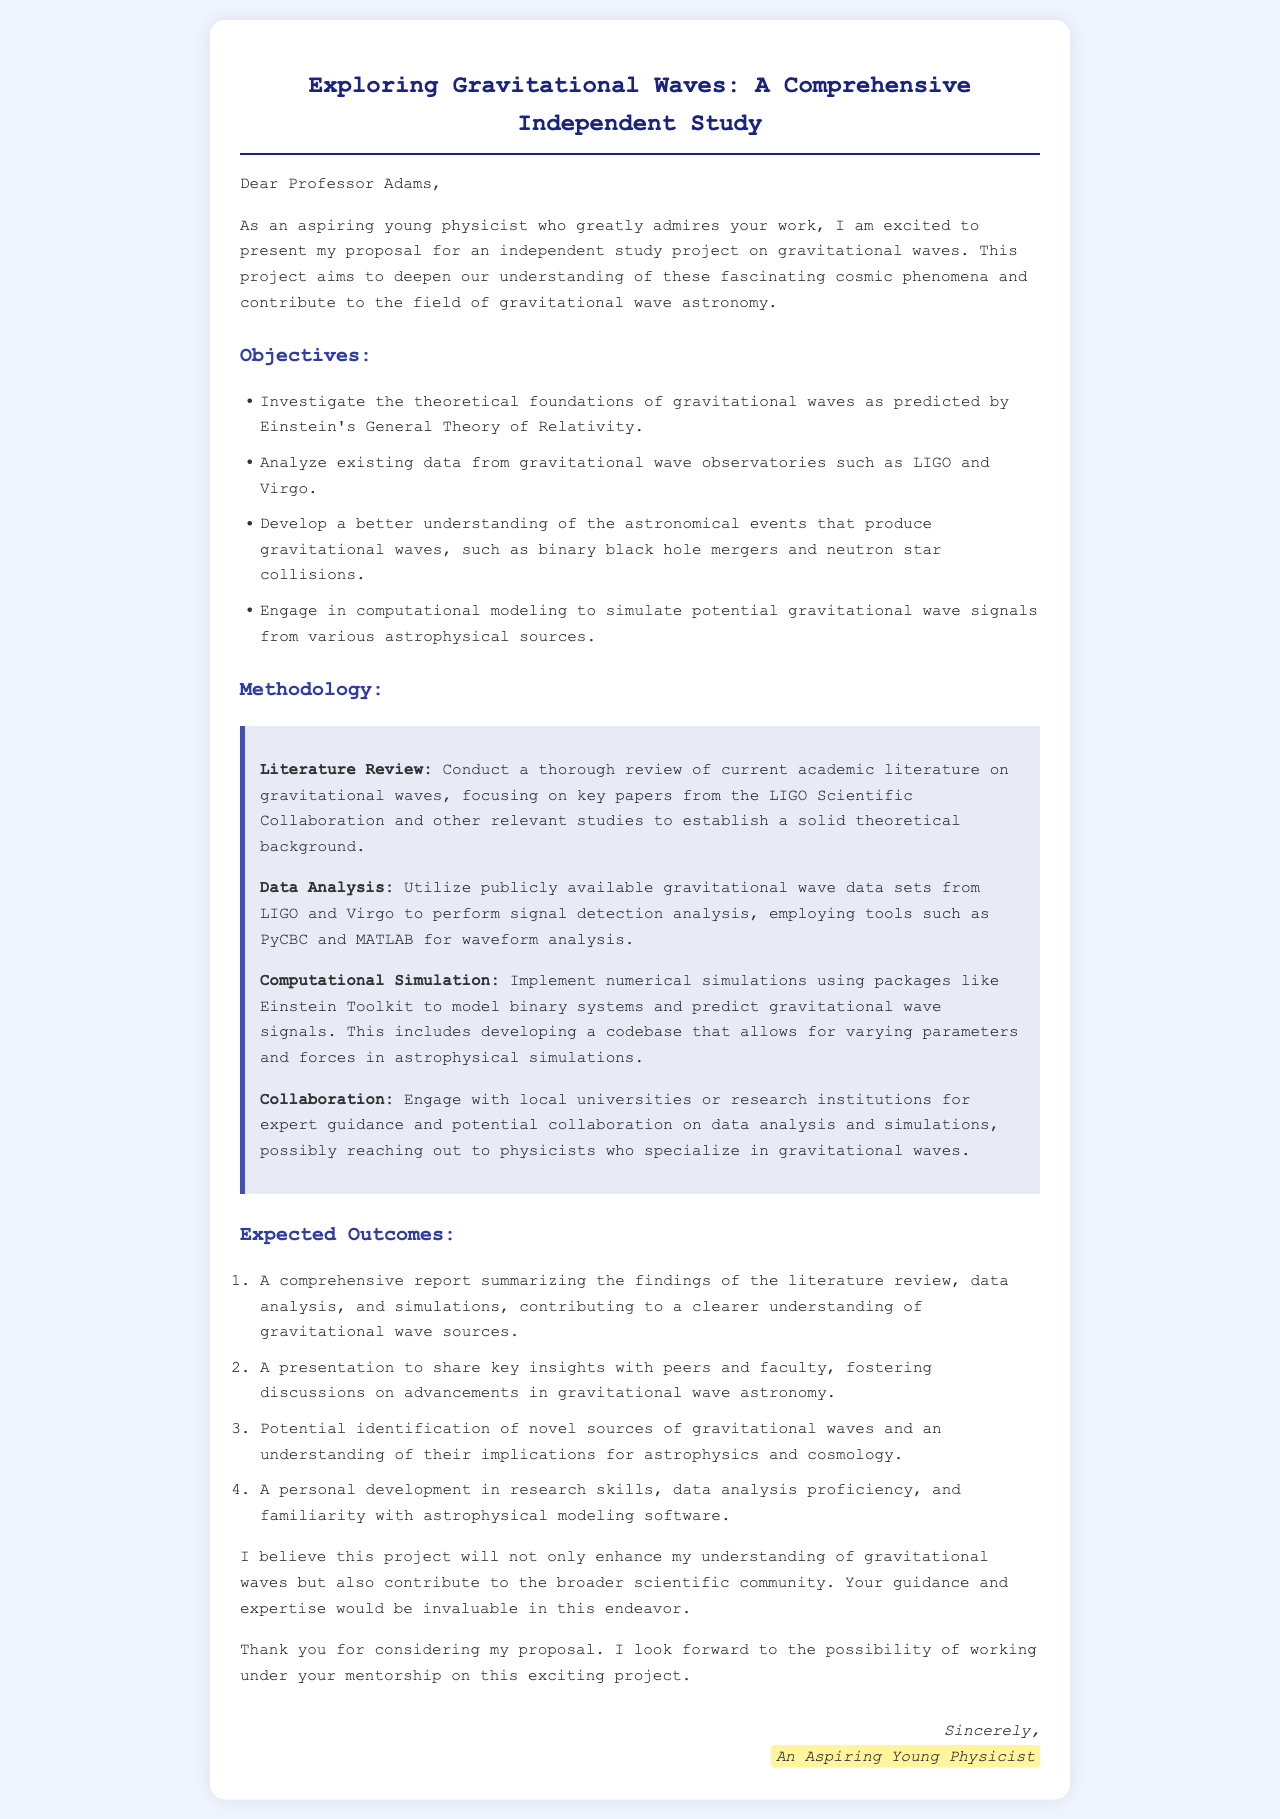What is the title of the proposal? The title of the proposal is presented at the top of the document.
Answer: Exploring Gravitational Waves: A Comprehensive Independent Study Who is the proposal addressed to? The opening greeting addresses a specific individual, which indicates the recipient of the proposal.
Answer: Professor Adams What is the first objective listed in the proposal? The objectives are outlined in bulleted form, and the first one can be directly identified.
Answer: Investigate the theoretical foundations of gravitational waves as predicted by Einstein's General Theory of Relativity What methodology involves using PyCBC and MATLAB? The methodology section describes data analysis tools and techniques, specifically related to signal detection.
Answer: Data Analysis What is one expected outcome of the study? The expected outcomes are numbered and summarize the anticipated results of the study.
Answer: A comprehensive report summarizing the findings of the literature review, data analysis, and simulations What type of collaboration does the proposal suggest? The methodology mentions engaging with others for expert guidance on specific aspects of the project.
Answer: Collaboration with local universities or research institutions How many key points are listed under "Methodology"? The methodology section is structured with distinct points that outline various methods employed in the study.
Answer: Four What background knowledge is necessary according to the methodology? The proposal emphasizes the importance of reviewing existing literature to ground the study in credible scientific knowledge.
Answer: Theoretical background on gravitational waves What personal development does the author hope to achieve? Expected outcomes include personal improvements in specific skills or knowledge derived from the research experience.
Answer: Research skills, data analysis proficiency, and familiarity with astrophysical modeling software 